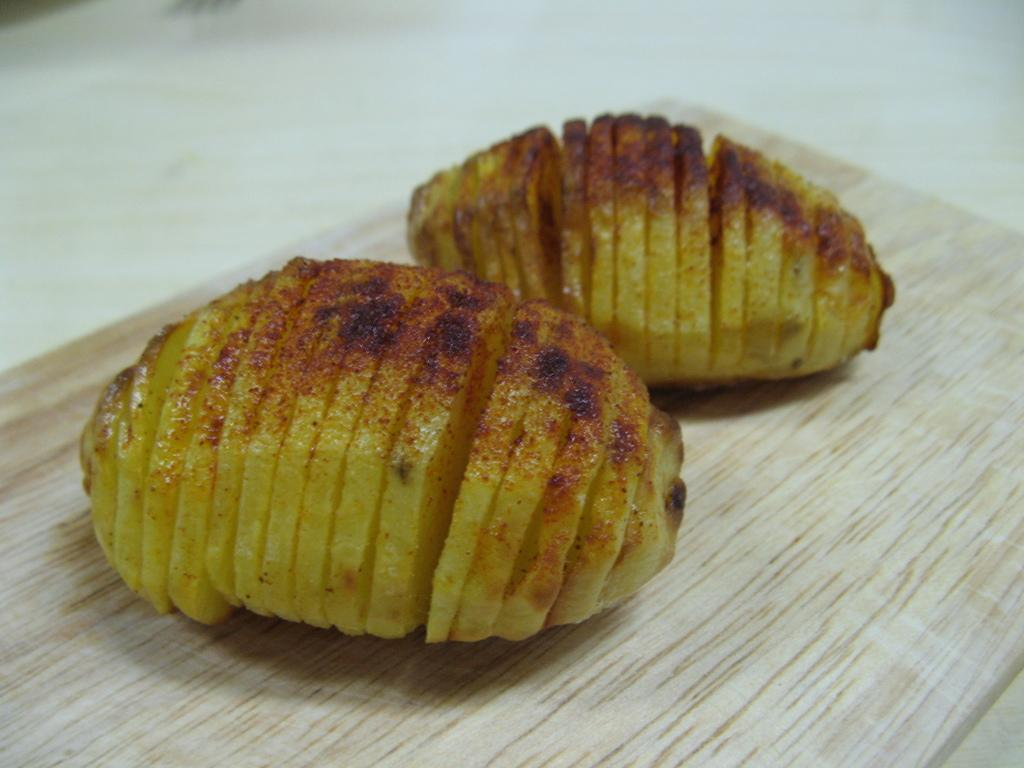What type of food can be seen on the chopping board in the image? There are baked potatoes on a chopping board in the image. Where is the chopping board located? The chopping board is on a table. What seasoning is present on the baked potatoes? Chili powder is present on the baked potatoes. What type of plant can be seen growing on the baked potatoes in the image? There are no plants growing on the baked potatoes in the image. What type of pies are being served alongside the baked potatoes in the image? There are no pies present in the image; it only features baked potatoes with chili powder. 